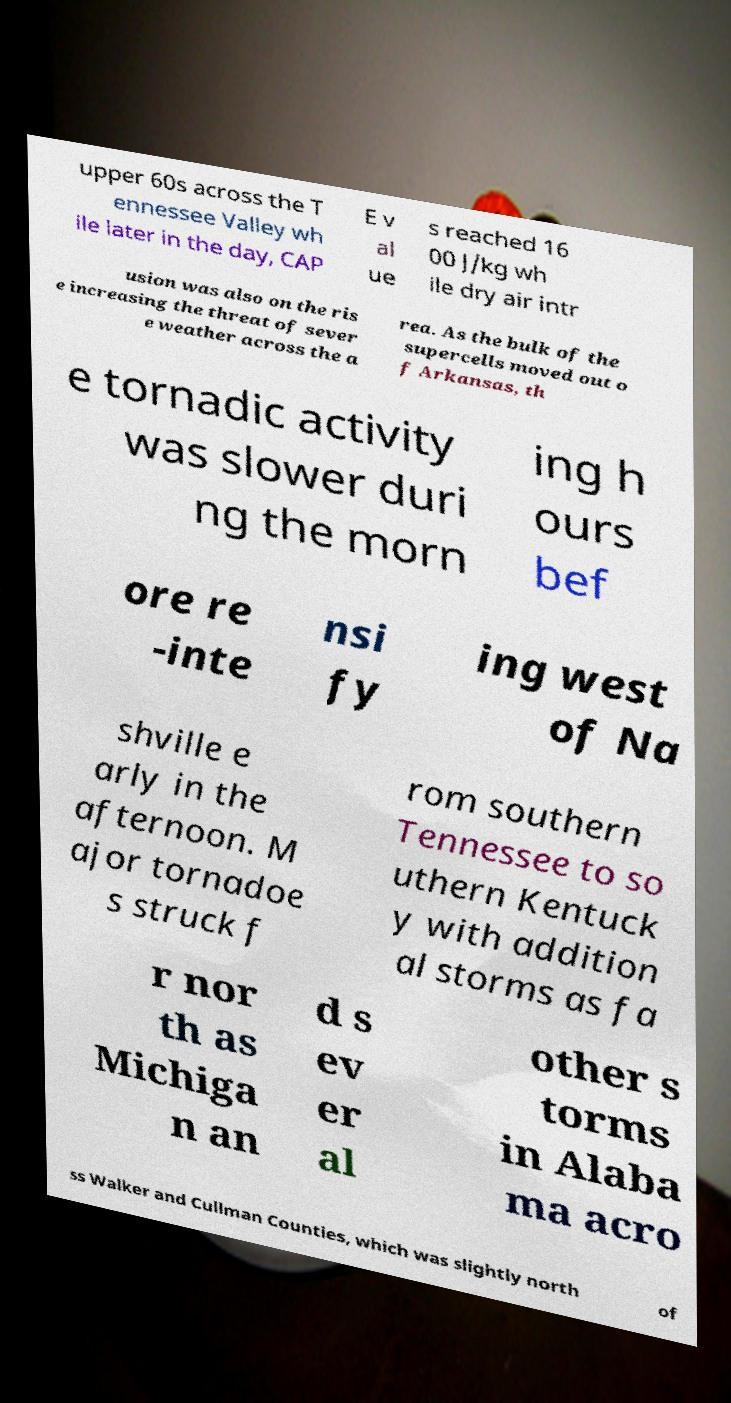What messages or text are displayed in this image? I need them in a readable, typed format. upper 60s across the T ennessee Valley wh ile later in the day, CAP E v al ue s reached 16 00 J/kg wh ile dry air intr usion was also on the ris e increasing the threat of sever e weather across the a rea. As the bulk of the supercells moved out o f Arkansas, th e tornadic activity was slower duri ng the morn ing h ours bef ore re -inte nsi fy ing west of Na shville e arly in the afternoon. M ajor tornadoe s struck f rom southern Tennessee to so uthern Kentuck y with addition al storms as fa r nor th as Michiga n an d s ev er al other s torms in Alaba ma acro ss Walker and Cullman Counties, which was slightly north of 